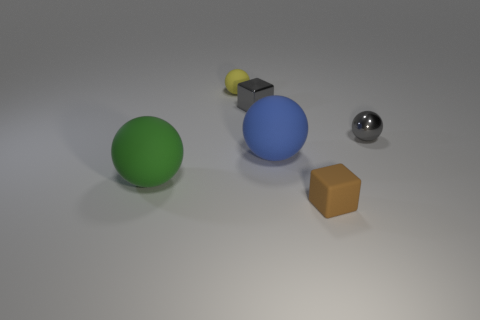There is a tiny block behind the green matte sphere; what number of large balls are behind it?
Make the answer very short. 0. What size is the sphere that is on the right side of the yellow rubber object and to the left of the small gray sphere?
Offer a very short reply. Large. How many metal objects are either small cylinders or big green objects?
Your answer should be very brief. 0. What is the tiny gray cube made of?
Offer a terse response. Metal. What material is the tiny gray object on the left side of the block on the right side of the gray metal object left of the small brown matte object?
Ensure brevity in your answer.  Metal. What is the shape of the yellow thing that is the same size as the brown block?
Give a very brief answer. Sphere. What number of objects are small brown matte objects or large objects that are to the right of the large green ball?
Keep it short and to the point. 2. Do the tiny ball in front of the yellow sphere and the gray thing on the left side of the brown block have the same material?
Provide a short and direct response. Yes. There is a shiny object that is the same color as the metal ball; what is its shape?
Give a very brief answer. Cube. How many purple things are either small matte blocks or spheres?
Keep it short and to the point. 0. 